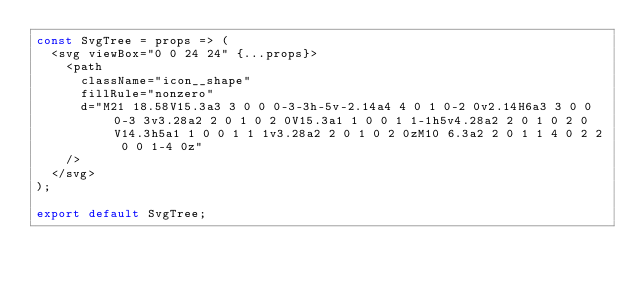<code> <loc_0><loc_0><loc_500><loc_500><_JavaScript_>const SvgTree = props => (
  <svg viewBox="0 0 24 24" {...props}>
    <path
      className="icon__shape"
      fillRule="nonzero"
      d="M21 18.58V15.3a3 3 0 0 0-3-3h-5v-2.14a4 4 0 1 0-2 0v2.14H6a3 3 0 0 0-3 3v3.28a2 2 0 1 0 2 0V15.3a1 1 0 0 1 1-1h5v4.28a2 2 0 1 0 2 0V14.3h5a1 1 0 0 1 1 1v3.28a2 2 0 1 0 2 0zM10 6.3a2 2 0 1 1 4 0 2 2 0 0 1-4 0z"
    />
  </svg>
);

export default SvgTree;
</code> 